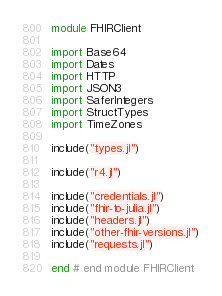<code> <loc_0><loc_0><loc_500><loc_500><_Julia_>module FHIRClient

import Base64
import Dates
import HTTP
import JSON3
import SaferIntegers
import StructTypes
import TimeZones

include("types.jl")

include("r4.jl")

include("credentials.jl")
include("fhir-to-julia.jl")
include("headers.jl")
include("other-fhir-versions.jl")
include("requests.jl")

end # end module FHIRClient
</code> 